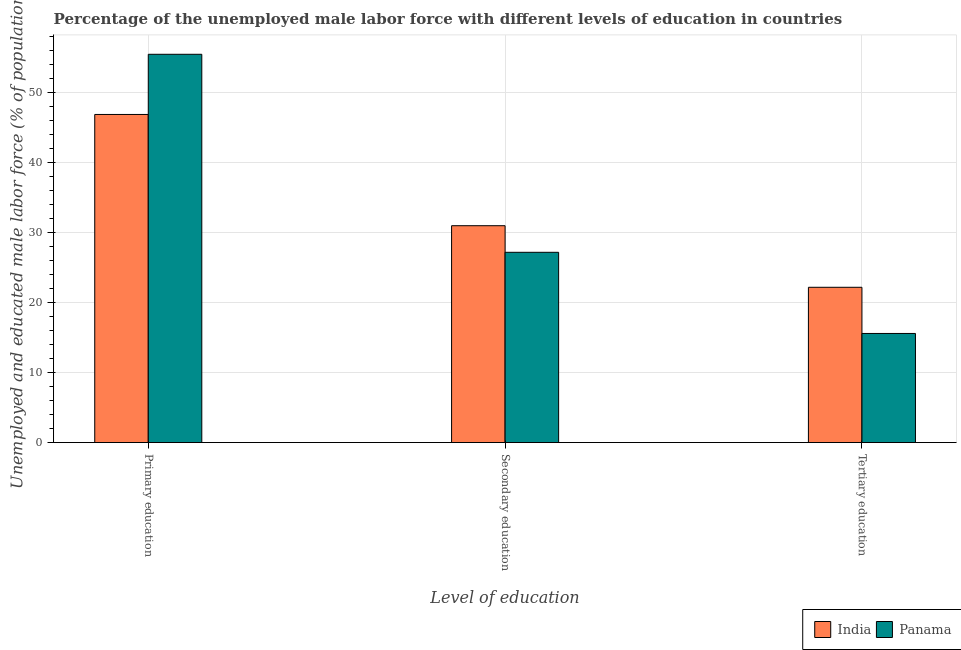How many groups of bars are there?
Your answer should be compact. 3. How many bars are there on the 1st tick from the left?
Offer a very short reply. 2. How many bars are there on the 3rd tick from the right?
Give a very brief answer. 2. What is the percentage of male labor force who received tertiary education in India?
Ensure brevity in your answer.  22.2. Across all countries, what is the maximum percentage of male labor force who received primary education?
Provide a short and direct response. 55.5. Across all countries, what is the minimum percentage of male labor force who received primary education?
Your answer should be compact. 46.9. In which country was the percentage of male labor force who received tertiary education maximum?
Give a very brief answer. India. In which country was the percentage of male labor force who received tertiary education minimum?
Your response must be concise. Panama. What is the total percentage of male labor force who received primary education in the graph?
Ensure brevity in your answer.  102.4. What is the difference between the percentage of male labor force who received secondary education in India and that in Panama?
Provide a succinct answer. 3.8. What is the difference between the percentage of male labor force who received primary education in India and the percentage of male labor force who received tertiary education in Panama?
Give a very brief answer. 31.3. What is the average percentage of male labor force who received tertiary education per country?
Give a very brief answer. 18.9. What is the difference between the percentage of male labor force who received secondary education and percentage of male labor force who received primary education in Panama?
Make the answer very short. -28.3. What is the ratio of the percentage of male labor force who received tertiary education in India to that in Panama?
Provide a short and direct response. 1.42. Is the difference between the percentage of male labor force who received primary education in Panama and India greater than the difference between the percentage of male labor force who received secondary education in Panama and India?
Give a very brief answer. Yes. What is the difference between the highest and the second highest percentage of male labor force who received secondary education?
Ensure brevity in your answer.  3.8. What is the difference between the highest and the lowest percentage of male labor force who received primary education?
Make the answer very short. 8.6. Is the sum of the percentage of male labor force who received primary education in Panama and India greater than the maximum percentage of male labor force who received secondary education across all countries?
Provide a succinct answer. Yes. What does the 1st bar from the left in Tertiary education represents?
Your response must be concise. India. What does the 2nd bar from the right in Primary education represents?
Provide a succinct answer. India. Are all the bars in the graph horizontal?
Provide a succinct answer. No. How many countries are there in the graph?
Provide a succinct answer. 2. What is the difference between two consecutive major ticks on the Y-axis?
Keep it short and to the point. 10. Are the values on the major ticks of Y-axis written in scientific E-notation?
Ensure brevity in your answer.  No. Does the graph contain grids?
Your answer should be compact. Yes. How are the legend labels stacked?
Provide a short and direct response. Horizontal. What is the title of the graph?
Your answer should be compact. Percentage of the unemployed male labor force with different levels of education in countries. Does "Europe(developing only)" appear as one of the legend labels in the graph?
Your answer should be compact. No. What is the label or title of the X-axis?
Keep it short and to the point. Level of education. What is the label or title of the Y-axis?
Give a very brief answer. Unemployed and educated male labor force (% of population). What is the Unemployed and educated male labor force (% of population) in India in Primary education?
Provide a short and direct response. 46.9. What is the Unemployed and educated male labor force (% of population) in Panama in Primary education?
Provide a succinct answer. 55.5. What is the Unemployed and educated male labor force (% of population) of India in Secondary education?
Provide a succinct answer. 31. What is the Unemployed and educated male labor force (% of population) of Panama in Secondary education?
Ensure brevity in your answer.  27.2. What is the Unemployed and educated male labor force (% of population) of India in Tertiary education?
Your response must be concise. 22.2. What is the Unemployed and educated male labor force (% of population) in Panama in Tertiary education?
Your response must be concise. 15.6. Across all Level of education, what is the maximum Unemployed and educated male labor force (% of population) of India?
Offer a very short reply. 46.9. Across all Level of education, what is the maximum Unemployed and educated male labor force (% of population) in Panama?
Your answer should be very brief. 55.5. Across all Level of education, what is the minimum Unemployed and educated male labor force (% of population) of India?
Provide a short and direct response. 22.2. Across all Level of education, what is the minimum Unemployed and educated male labor force (% of population) of Panama?
Keep it short and to the point. 15.6. What is the total Unemployed and educated male labor force (% of population) of India in the graph?
Your response must be concise. 100.1. What is the total Unemployed and educated male labor force (% of population) in Panama in the graph?
Offer a terse response. 98.3. What is the difference between the Unemployed and educated male labor force (% of population) in Panama in Primary education and that in Secondary education?
Keep it short and to the point. 28.3. What is the difference between the Unemployed and educated male labor force (% of population) in India in Primary education and that in Tertiary education?
Your answer should be compact. 24.7. What is the difference between the Unemployed and educated male labor force (% of population) in Panama in Primary education and that in Tertiary education?
Your answer should be very brief. 39.9. What is the difference between the Unemployed and educated male labor force (% of population) in India in Primary education and the Unemployed and educated male labor force (% of population) in Panama in Secondary education?
Make the answer very short. 19.7. What is the difference between the Unemployed and educated male labor force (% of population) of India in Primary education and the Unemployed and educated male labor force (% of population) of Panama in Tertiary education?
Keep it short and to the point. 31.3. What is the difference between the Unemployed and educated male labor force (% of population) in India in Secondary education and the Unemployed and educated male labor force (% of population) in Panama in Tertiary education?
Ensure brevity in your answer.  15.4. What is the average Unemployed and educated male labor force (% of population) of India per Level of education?
Your answer should be compact. 33.37. What is the average Unemployed and educated male labor force (% of population) in Panama per Level of education?
Offer a very short reply. 32.77. What is the difference between the Unemployed and educated male labor force (% of population) in India and Unemployed and educated male labor force (% of population) in Panama in Tertiary education?
Provide a succinct answer. 6.6. What is the ratio of the Unemployed and educated male labor force (% of population) in India in Primary education to that in Secondary education?
Give a very brief answer. 1.51. What is the ratio of the Unemployed and educated male labor force (% of population) of Panama in Primary education to that in Secondary education?
Make the answer very short. 2.04. What is the ratio of the Unemployed and educated male labor force (% of population) of India in Primary education to that in Tertiary education?
Offer a very short reply. 2.11. What is the ratio of the Unemployed and educated male labor force (% of population) of Panama in Primary education to that in Tertiary education?
Offer a terse response. 3.56. What is the ratio of the Unemployed and educated male labor force (% of population) of India in Secondary education to that in Tertiary education?
Ensure brevity in your answer.  1.4. What is the ratio of the Unemployed and educated male labor force (% of population) of Panama in Secondary education to that in Tertiary education?
Ensure brevity in your answer.  1.74. What is the difference between the highest and the second highest Unemployed and educated male labor force (% of population) of India?
Keep it short and to the point. 15.9. What is the difference between the highest and the second highest Unemployed and educated male labor force (% of population) in Panama?
Give a very brief answer. 28.3. What is the difference between the highest and the lowest Unemployed and educated male labor force (% of population) in India?
Your answer should be compact. 24.7. What is the difference between the highest and the lowest Unemployed and educated male labor force (% of population) of Panama?
Give a very brief answer. 39.9. 